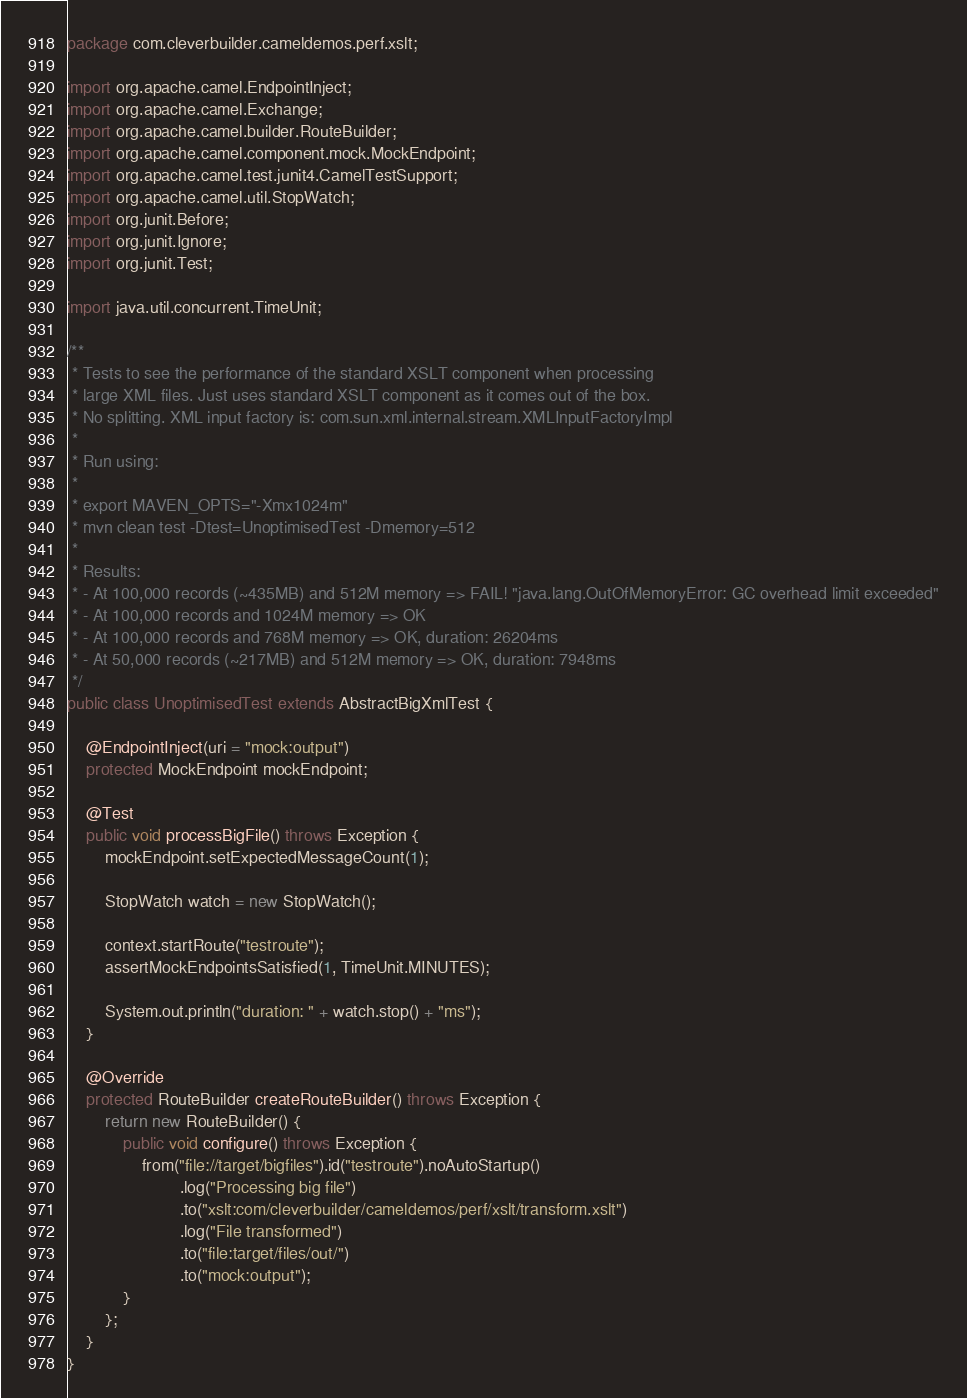<code> <loc_0><loc_0><loc_500><loc_500><_Java_>package com.cleverbuilder.cameldemos.perf.xslt;

import org.apache.camel.EndpointInject;
import org.apache.camel.Exchange;
import org.apache.camel.builder.RouteBuilder;
import org.apache.camel.component.mock.MockEndpoint;
import org.apache.camel.test.junit4.CamelTestSupport;
import org.apache.camel.util.StopWatch;
import org.junit.Before;
import org.junit.Ignore;
import org.junit.Test;

import java.util.concurrent.TimeUnit;

/**
 * Tests to see the performance of the standard XSLT component when processing
 * large XML files. Just uses standard XSLT component as it comes out of the box.
 * No splitting. XML input factory is: com.sun.xml.internal.stream.XMLInputFactoryImpl
 *
 * Run using:
 *
 * export MAVEN_OPTS="-Xmx1024m"
 * mvn clean test -Dtest=UnoptimisedTest -Dmemory=512
 *
 * Results:
 * - At 100,000 records (~435MB) and 512M memory => FAIL! "java.lang.OutOfMemoryError: GC overhead limit exceeded"
 * - At 100,000 records and 1024M memory => OK
 * - At 100,000 records and 768M memory => OK, duration: 26204ms
 * - At 50,000 records (~217MB) and 512M memory => OK, duration: 7948ms
 */
public class UnoptimisedTest extends AbstractBigXmlTest {

    @EndpointInject(uri = "mock:output")
    protected MockEndpoint mockEndpoint;

    @Test
    public void processBigFile() throws Exception {
        mockEndpoint.setExpectedMessageCount(1);

        StopWatch watch = new StopWatch();

        context.startRoute("testroute");
        assertMockEndpointsSatisfied(1, TimeUnit.MINUTES);

        System.out.println("duration: " + watch.stop() + "ms");
    }

    @Override
    protected RouteBuilder createRouteBuilder() throws Exception {
        return new RouteBuilder() {
            public void configure() throws Exception {
                from("file://target/bigfiles").id("testroute").noAutoStartup()
                        .log("Processing big file")
                        .to("xslt:com/cleverbuilder/cameldemos/perf/xslt/transform.xslt")
                        .log("File transformed")
                        .to("file:target/files/out/")
                        .to("mock:output");
            }
        };
    }
}
</code> 